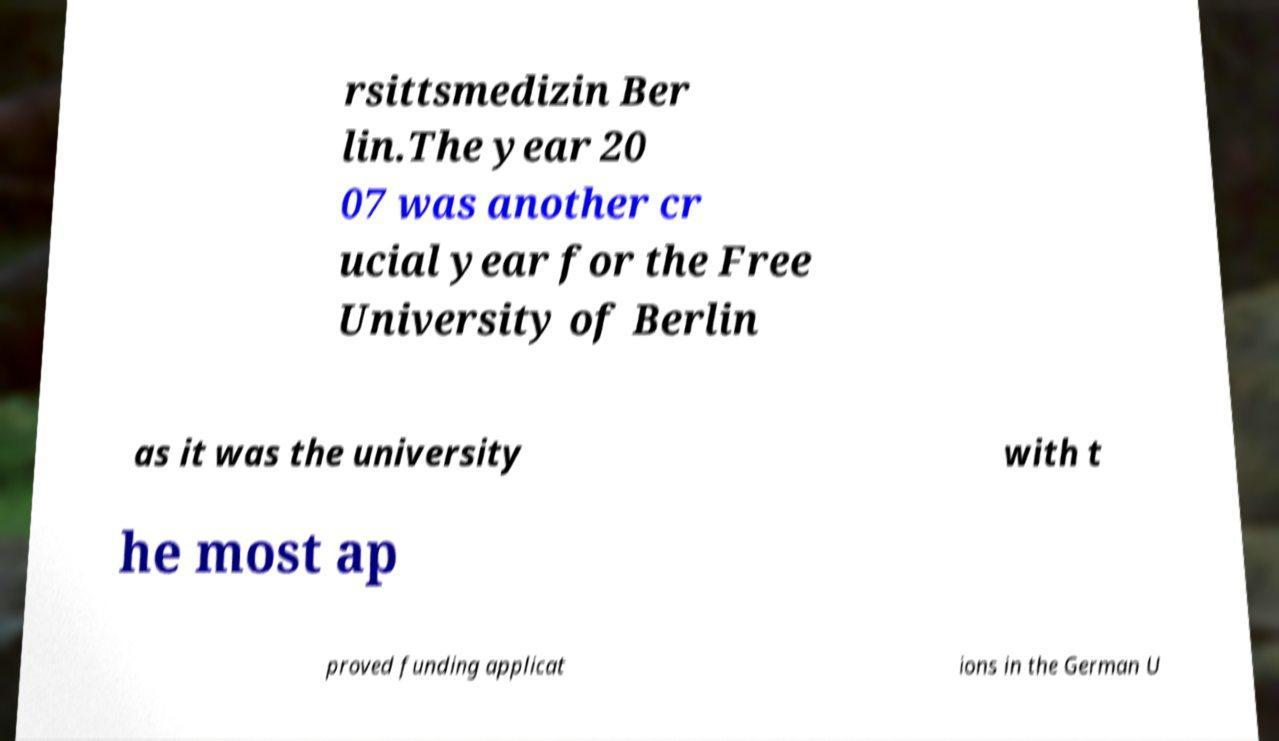For documentation purposes, I need the text within this image transcribed. Could you provide that? rsittsmedizin Ber lin.The year 20 07 was another cr ucial year for the Free University of Berlin as it was the university with t he most ap proved funding applicat ions in the German U 